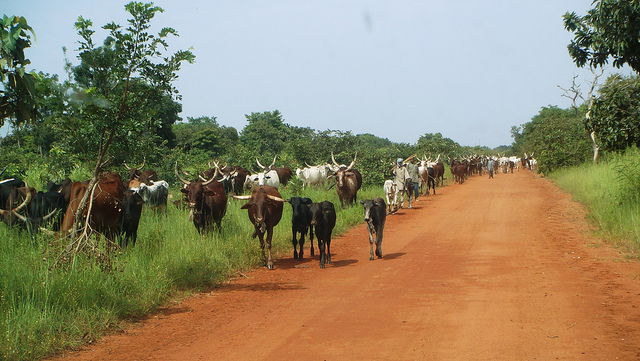<image>How many bulls are there? I am not sure how many bulls there are. It can be over a dozen or even hundreds. How many bulls are there? I don't know the exact number of bulls. But there are over a dozen bulls in the image. 